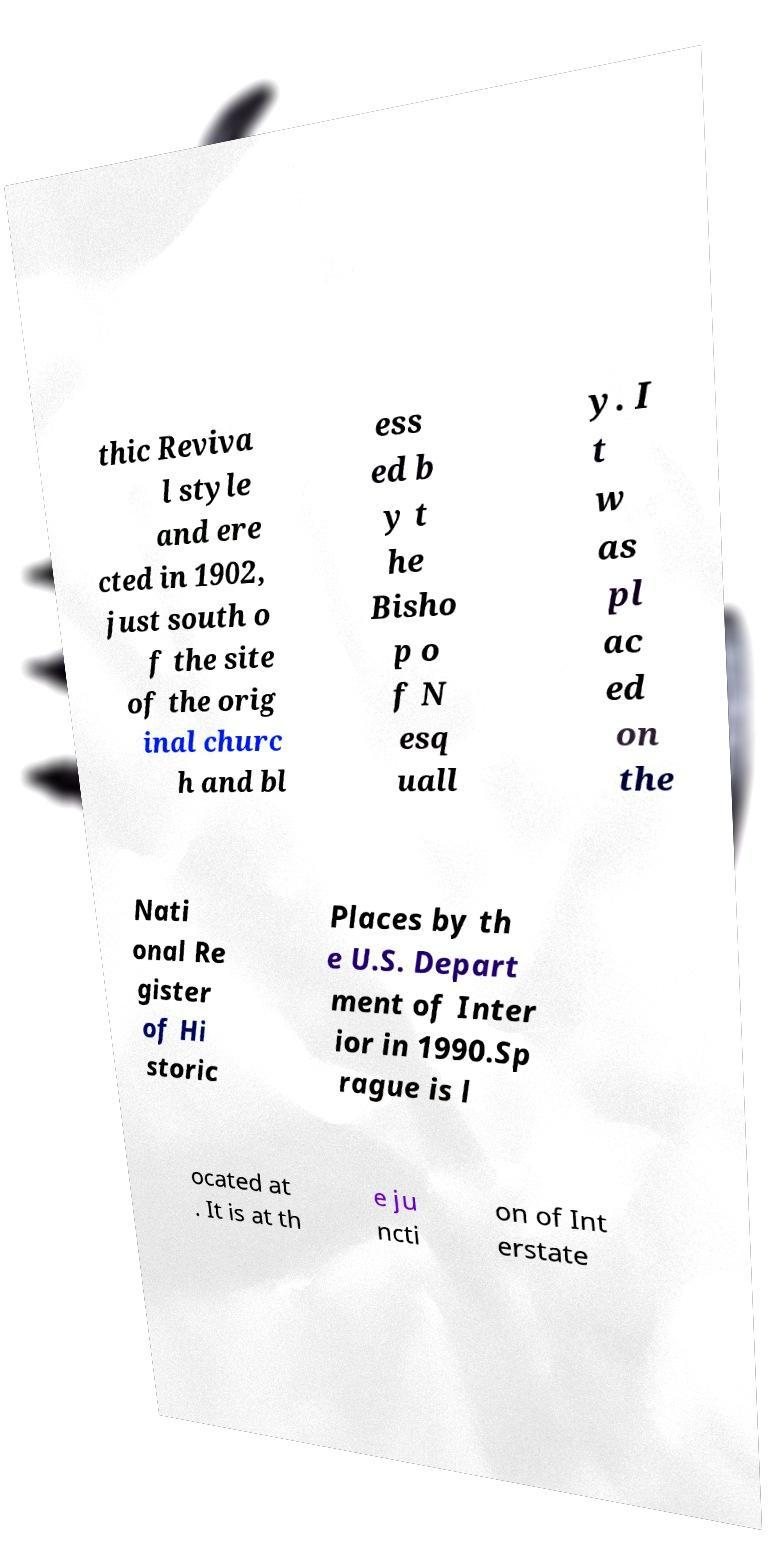What messages or text are displayed in this image? I need them in a readable, typed format. thic Reviva l style and ere cted in 1902, just south o f the site of the orig inal churc h and bl ess ed b y t he Bisho p o f N esq uall y. I t w as pl ac ed on the Nati onal Re gister of Hi storic Places by th e U.S. Depart ment of Inter ior in 1990.Sp rague is l ocated at . It is at th e ju ncti on of Int erstate 